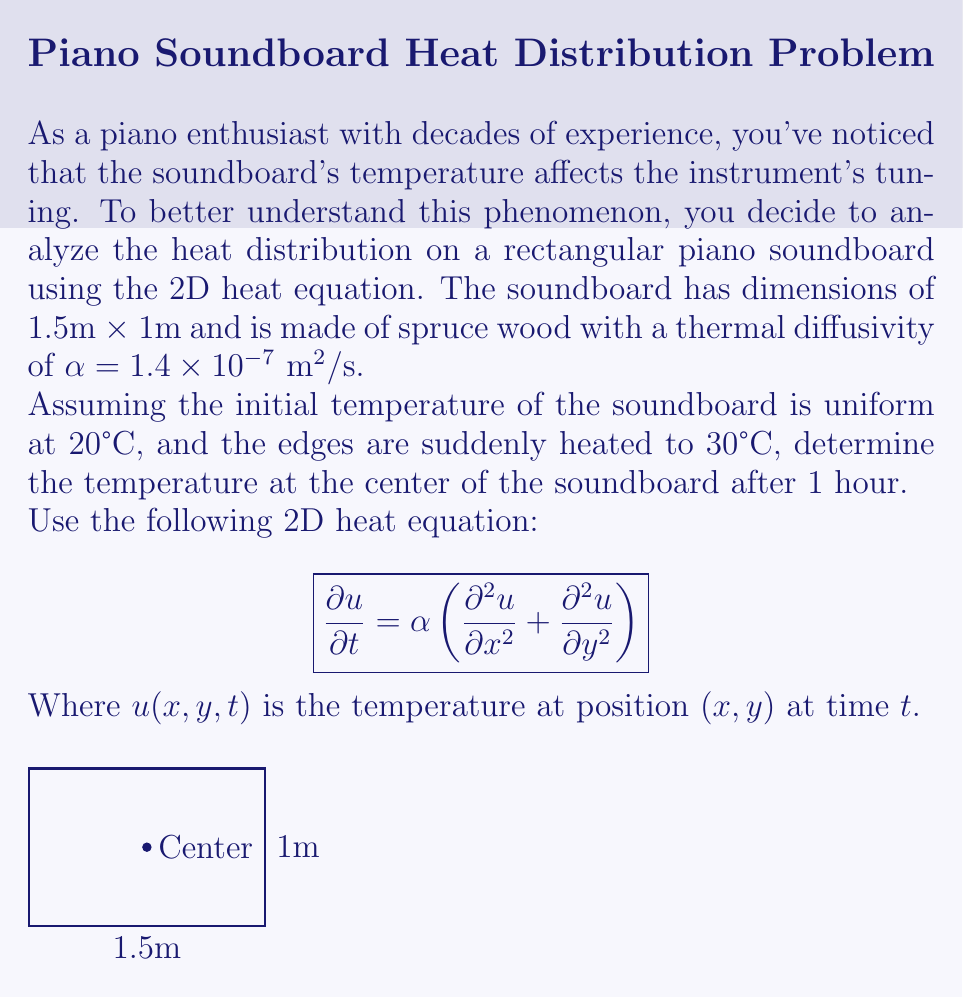Give your solution to this math problem. To solve this problem, we'll use the analytical solution for the 2D heat equation with constant boundary conditions. The solution is given by:

$$u(x,y,t) = u_f + \sum_{m=1}^{\infty}\sum_{n=1}^{\infty}A_{mn}\sin\left(\frac{m\pi x}{L_x}\right)\sin\left(\frac{n\pi y}{L_y}\right)e^{-\alpha t\left(\frac{m^2\pi^2}{L_x^2}+\frac{n^2\pi^2}{L_y^2}\right)}$$

Where:
- $u_f$ is the final steady-state temperature (30°C)
- $L_x = 1.5\text{ m}$ and $L_y = 1\text{ m}$ are the dimensions of the soundboard
- $A_{mn}$ are the Fourier coefficients

For our initial conditions:
$$A_{mn} = \frac{4(u_i - u_f)}{mn\pi^2}\left[1-(-1)^m\right]\left[1-(-1)^n\right]$$

Where $u_i = 20°C$ is the initial temperature.

At the center of the soundboard, $x = 0.75\text{ m}$ and $y = 0.5\text{ m}$. After 1 hour, $t = 3600\text{ s}$.

Substituting these values and using a computer algebra system to evaluate the series (taking the first 10 terms for each sum), we get:

$$u(0.75, 0.5, 3600) \approx 29.32°C$$

This result shows that after 1 hour, the temperature at the center of the soundboard has increased from 20°C to approximately 29.32°C, approaching the boundary temperature of 30°C.
Answer: 29.32°C 